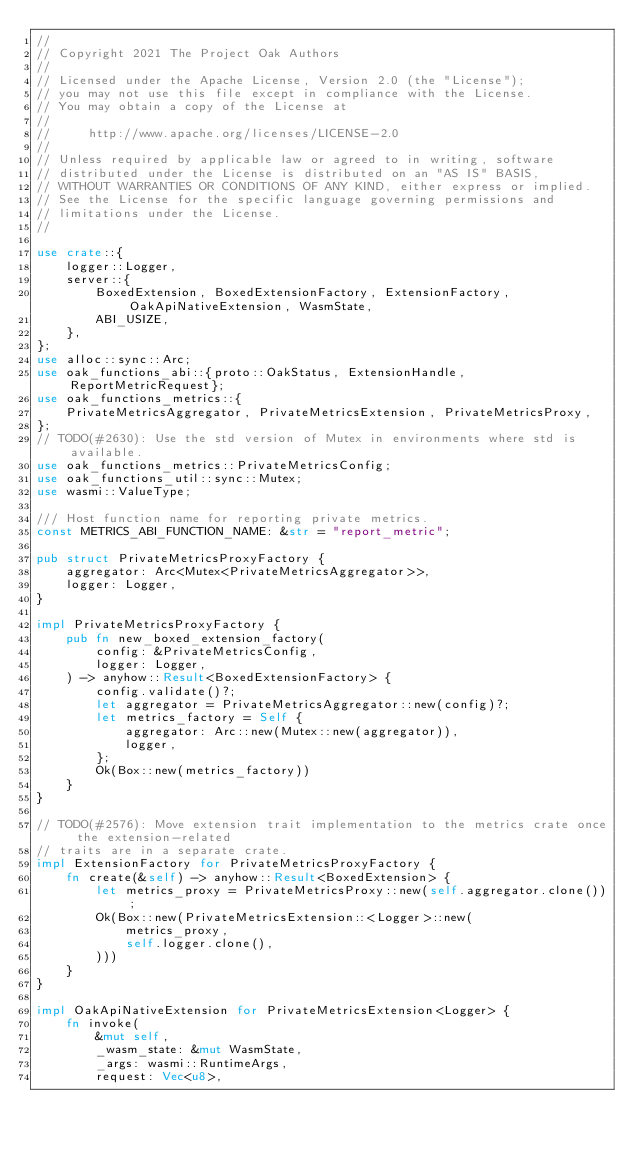Convert code to text. <code><loc_0><loc_0><loc_500><loc_500><_Rust_>//
// Copyright 2021 The Project Oak Authors
//
// Licensed under the Apache License, Version 2.0 (the "License");
// you may not use this file except in compliance with the License.
// You may obtain a copy of the License at
//
//     http://www.apache.org/licenses/LICENSE-2.0
//
// Unless required by applicable law or agreed to in writing, software
// distributed under the License is distributed on an "AS IS" BASIS,
// WITHOUT WARRANTIES OR CONDITIONS OF ANY KIND, either express or implied.
// See the License for the specific language governing permissions and
// limitations under the License.
//

use crate::{
    logger::Logger,
    server::{
        BoxedExtension, BoxedExtensionFactory, ExtensionFactory, OakApiNativeExtension, WasmState,
        ABI_USIZE,
    },
};
use alloc::sync::Arc;
use oak_functions_abi::{proto::OakStatus, ExtensionHandle, ReportMetricRequest};
use oak_functions_metrics::{
    PrivateMetricsAggregator, PrivateMetricsExtension, PrivateMetricsProxy,
};
// TODO(#2630): Use the std version of Mutex in environments where std is available.
use oak_functions_metrics::PrivateMetricsConfig;
use oak_functions_util::sync::Mutex;
use wasmi::ValueType;

/// Host function name for reporting private metrics.
const METRICS_ABI_FUNCTION_NAME: &str = "report_metric";

pub struct PrivateMetricsProxyFactory {
    aggregator: Arc<Mutex<PrivateMetricsAggregator>>,
    logger: Logger,
}

impl PrivateMetricsProxyFactory {
    pub fn new_boxed_extension_factory(
        config: &PrivateMetricsConfig,
        logger: Logger,
    ) -> anyhow::Result<BoxedExtensionFactory> {
        config.validate()?;
        let aggregator = PrivateMetricsAggregator::new(config)?;
        let metrics_factory = Self {
            aggregator: Arc::new(Mutex::new(aggregator)),
            logger,
        };
        Ok(Box::new(metrics_factory))
    }
}

// TODO(#2576): Move extension trait implementation to the metrics crate once the extension-related
// traits are in a separate crate.
impl ExtensionFactory for PrivateMetricsProxyFactory {
    fn create(&self) -> anyhow::Result<BoxedExtension> {
        let metrics_proxy = PrivateMetricsProxy::new(self.aggregator.clone());
        Ok(Box::new(PrivateMetricsExtension::<Logger>::new(
            metrics_proxy,
            self.logger.clone(),
        )))
    }
}

impl OakApiNativeExtension for PrivateMetricsExtension<Logger> {
    fn invoke(
        &mut self,
        _wasm_state: &mut WasmState,
        _args: wasmi::RuntimeArgs,
        request: Vec<u8>,</code> 